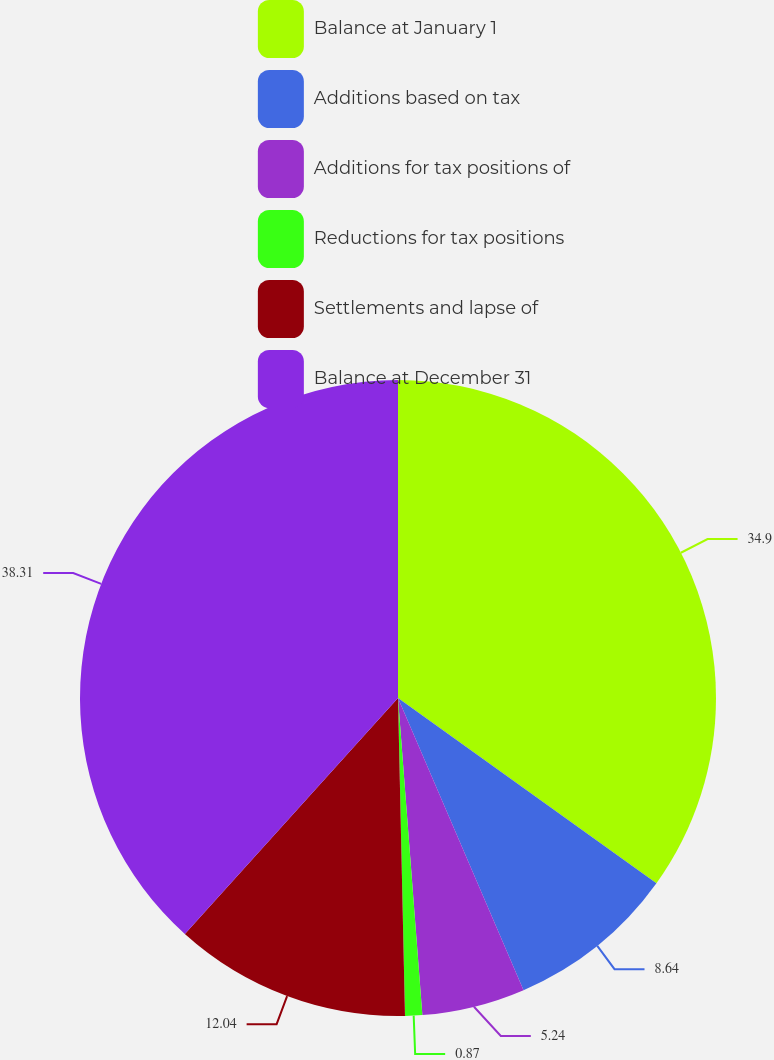Convert chart to OTSL. <chart><loc_0><loc_0><loc_500><loc_500><pie_chart><fcel>Balance at January 1<fcel>Additions based on tax<fcel>Additions for tax positions of<fcel>Reductions for tax positions<fcel>Settlements and lapse of<fcel>Balance at December 31<nl><fcel>34.9%<fcel>8.64%<fcel>5.24%<fcel>0.87%<fcel>12.04%<fcel>38.31%<nl></chart> 